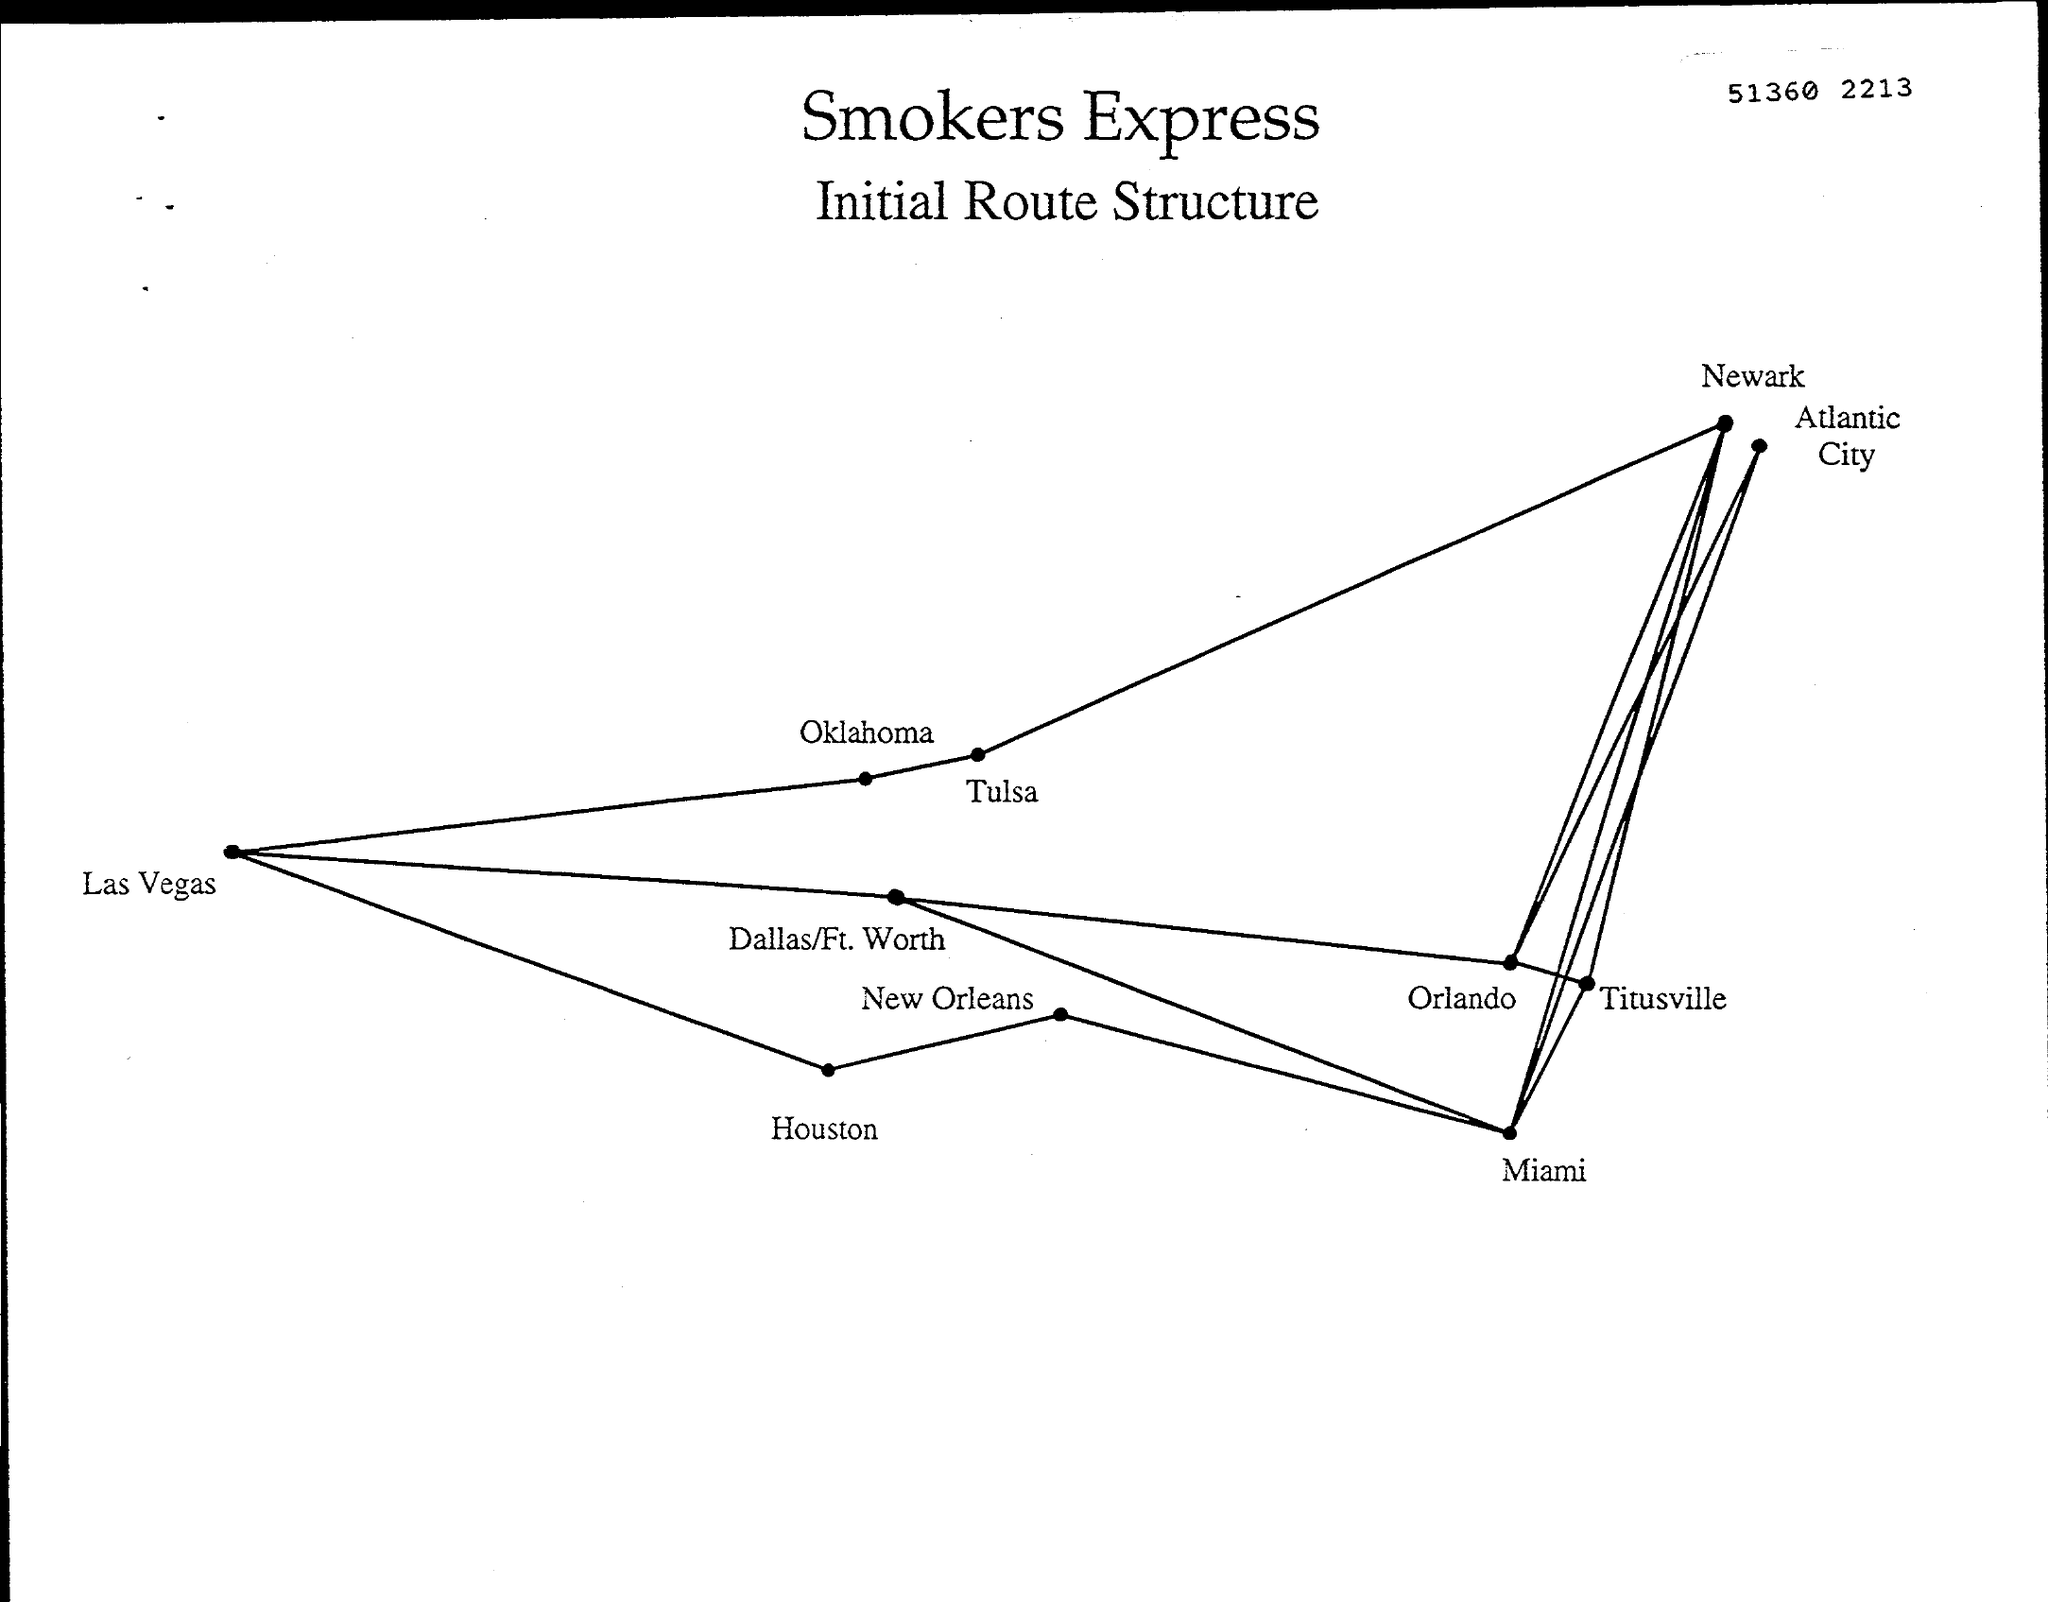Indicate a few pertinent items in this graphic. The title of the document is 'What is the document title? Smokers Express Initial Route Structure..'. The number on the document is 51360, and the document appears to be a receipt for a purchase made on February 21, 2023. 